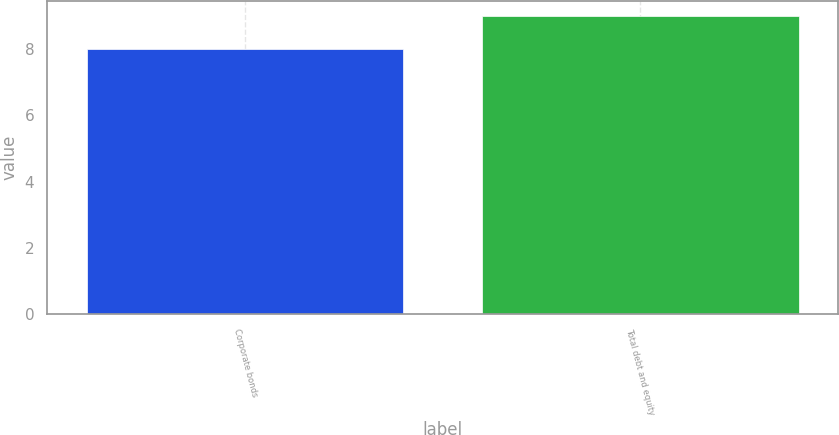Convert chart to OTSL. <chart><loc_0><loc_0><loc_500><loc_500><bar_chart><fcel>Corporate bonds<fcel>Total debt and equity<nl><fcel>8<fcel>9<nl></chart> 